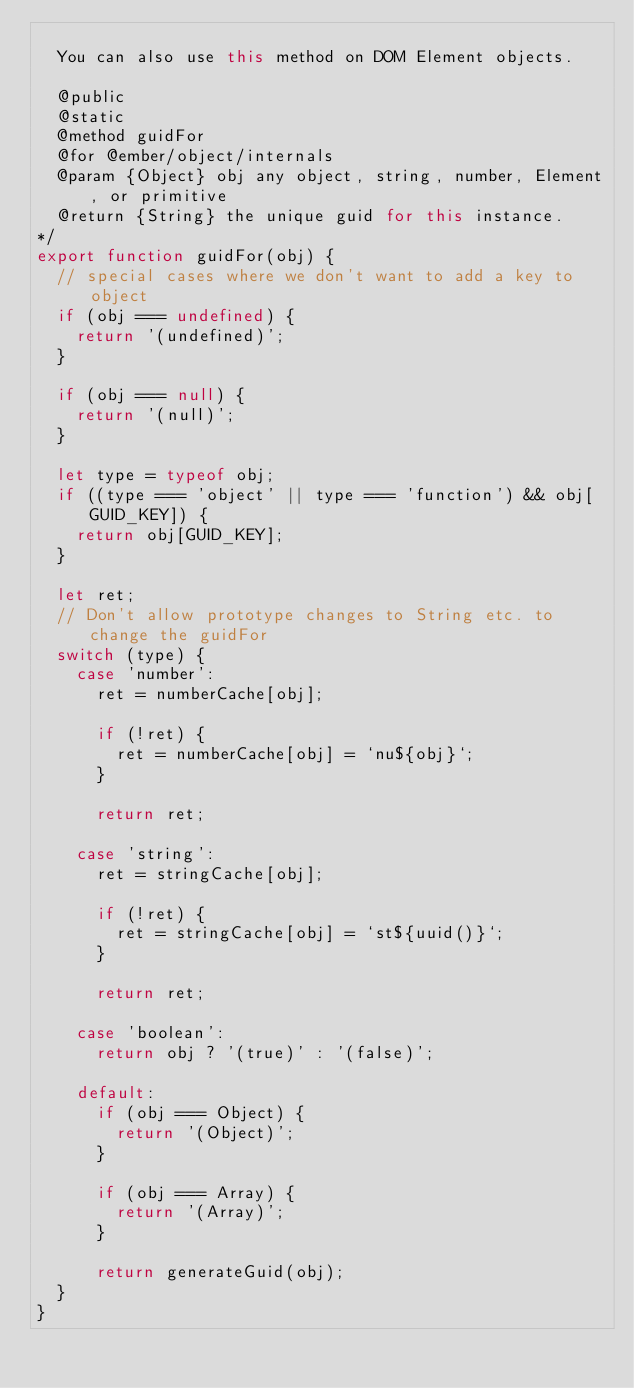<code> <loc_0><loc_0><loc_500><loc_500><_JavaScript_>
  You can also use this method on DOM Element objects.

  @public
  @static
  @method guidFor
  @for @ember/object/internals
  @param {Object} obj any object, string, number, Element, or primitive
  @return {String} the unique guid for this instance.
*/
export function guidFor(obj) {
  // special cases where we don't want to add a key to object
  if (obj === undefined) {
    return '(undefined)';
  }

  if (obj === null) {
    return '(null)';
  }

  let type = typeof obj;
  if ((type === 'object' || type === 'function') && obj[GUID_KEY]) {
    return obj[GUID_KEY];
  }

  let ret;
  // Don't allow prototype changes to String etc. to change the guidFor
  switch (type) {
    case 'number':
      ret = numberCache[obj];

      if (!ret) {
        ret = numberCache[obj] = `nu${obj}`;
      }

      return ret;

    case 'string':
      ret = stringCache[obj];

      if (!ret) {
        ret = stringCache[obj] = `st${uuid()}`;
      }

      return ret;

    case 'boolean':
      return obj ? '(true)' : '(false)';

    default:
      if (obj === Object) {
        return '(Object)';
      }

      if (obj === Array) {
        return '(Array)';
      }

      return generateGuid(obj);
  }
}
</code> 